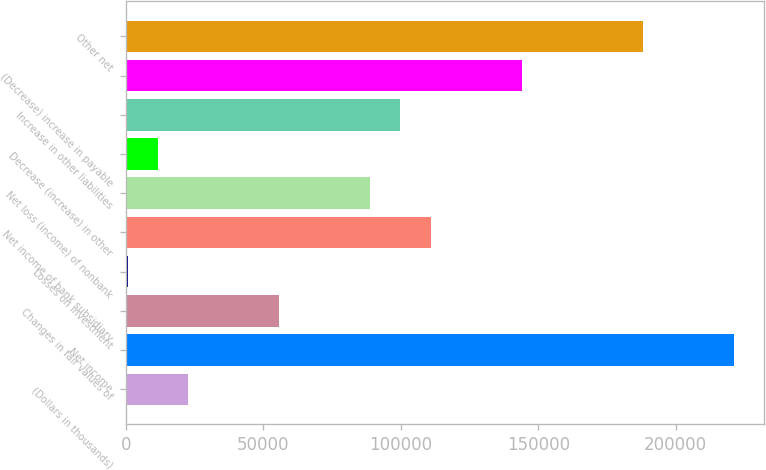<chart> <loc_0><loc_0><loc_500><loc_500><bar_chart><fcel>(Dollars in thousands)<fcel>Net income<fcel>Changes in fair values of<fcel>Losses on investment<fcel>Net income of bank subsidiary<fcel>Net loss (income) of nonbank<fcel>Decrease (increase) in other<fcel>Increase in other liabilities<fcel>(Decrease) increase in payable<fcel>Other net<nl><fcel>22618<fcel>221158<fcel>55708<fcel>558<fcel>110858<fcel>88798<fcel>11588<fcel>99828<fcel>143948<fcel>188068<nl></chart> 